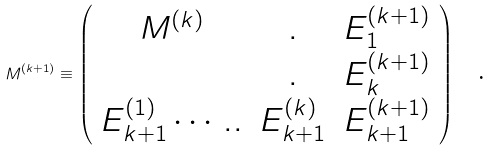<formula> <loc_0><loc_0><loc_500><loc_500>M ^ { ( k + 1 ) } \equiv \left ( \begin{array} { c c c } M ^ { ( k ) } & . & E _ { 1 } ^ { ( k + 1 ) } \\ & . & E _ { k } ^ { ( k + 1 ) } \\ E _ { k + 1 } ^ { ( 1 ) } \cdots . . & E _ { k + 1 } ^ { ( k ) } & E _ { k + 1 } ^ { ( k + 1 ) } \end{array} \right ) \text { \ .}</formula> 